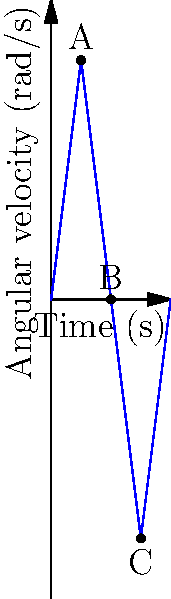A gymnast performs a somersault, and her angular velocity is represented by the graph above. At which point(s) does the gymnast experience the greatest angular acceleration, and what can you conclude about the direction of rotation at point B? Let's analyze this step-by-step:

1. Angular acceleration is the rate of change of angular velocity. Graphically, it's represented by the slope of the angular velocity curve.

2. Looking at the graph:
   - From 0 to 1 second (before point A): The slope is positive and steep.
   - From 1 to 2 seconds (A to B): The slope is negative and steep.
   - From 2 to 3 seconds (B to C): The slope is negative and steep.
   - From 3 to 4 seconds (after C): The slope is positive and steep.

3. The steepest slopes occur:
   - Just before point A
   - Just after point A
   - Just before point C
   - Just after point C

4. These points of steepest slope represent the greatest angular acceleration (or deceleration).

5. At point B:
   - The angular velocity is zero.
   - The curve passes from positive to negative.

6. This means at point B:
   - The gymnast momentarily stops rotating.
   - The direction of rotation reverses after this point.

Therefore, the gymnast experiences the greatest angular acceleration (or deceleration) just before and after points A and C. At point B, the gymnast momentarily stops rotating and then begins rotating in the opposite direction.
Answer: Greatest acceleration: before/after A and C. At B: rotation stops and reverses. 